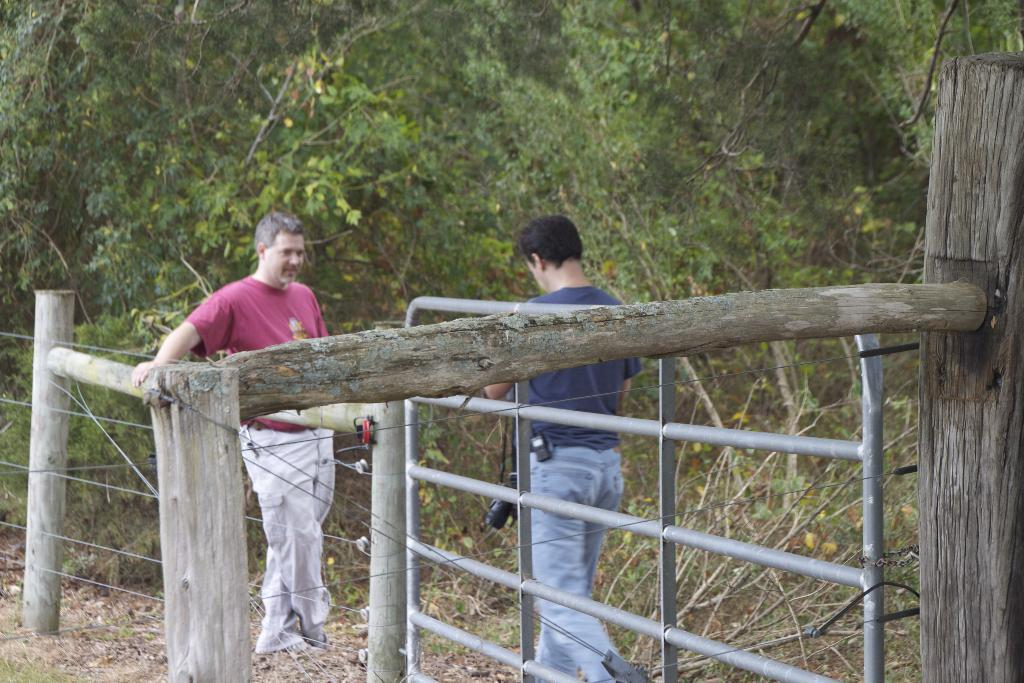What type of structure is present in the image? There is a metal gate in the image. How many people are visible in the image? Two persons are standing in the image. What material are the poles made of in the image? The poles in the image are made of wood. What type of barrier is present in the image? There is fencing in the image. What can be seen in the background of the image? There are trees in the background of the image. What color are the trees in the image? The trees are green in color. What type of cabbage is being used as fuel for the loaf in the image? There is no cabbage, fuel, or loaf present in the image. 